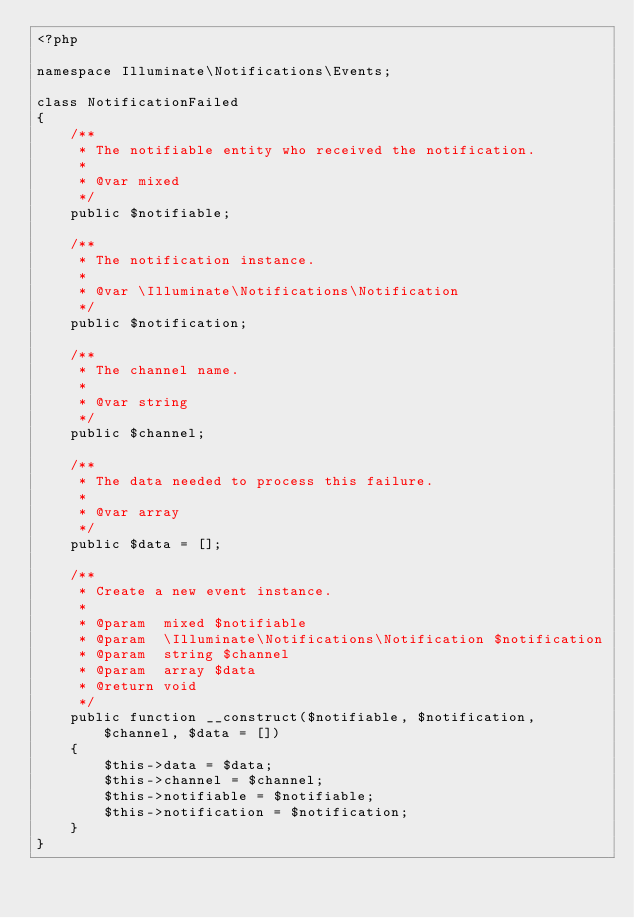<code> <loc_0><loc_0><loc_500><loc_500><_PHP_><?php

namespace Illuminate\Notifications\Events;

class NotificationFailed
{
    /**
     * The notifiable entity who received the notification.
     *
     * @var mixed
     */
    public $notifiable;

    /**
     * The notification instance.
     *
     * @var \Illuminate\Notifications\Notification
     */
    public $notification;

    /**
     * The channel name.
     *
     * @var string
     */
    public $channel;

    /**
     * The data needed to process this failure.
     *
     * @var array
     */
    public $data = [];

    /**
     * Create a new event instance.
     *
     * @param  mixed $notifiable
     * @param  \Illuminate\Notifications\Notification $notification
     * @param  string $channel
     * @param  array $data
     * @return void
     */
    public function __construct($notifiable, $notification, $channel, $data = [])
    {
        $this->data = $data;
        $this->channel = $channel;
        $this->notifiable = $notifiable;
        $this->notification = $notification;
    }
}
</code> 